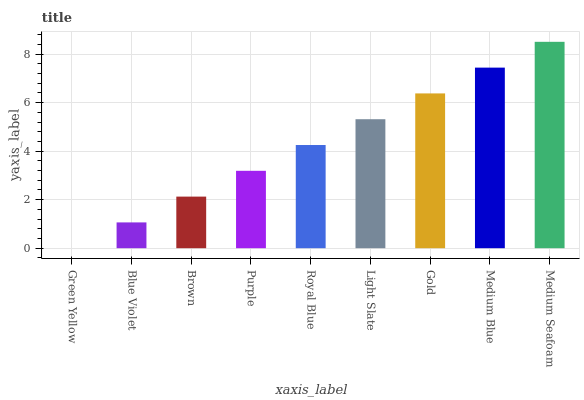Is Green Yellow the minimum?
Answer yes or no. Yes. Is Medium Seafoam the maximum?
Answer yes or no. Yes. Is Blue Violet the minimum?
Answer yes or no. No. Is Blue Violet the maximum?
Answer yes or no. No. Is Blue Violet greater than Green Yellow?
Answer yes or no. Yes. Is Green Yellow less than Blue Violet?
Answer yes or no. Yes. Is Green Yellow greater than Blue Violet?
Answer yes or no. No. Is Blue Violet less than Green Yellow?
Answer yes or no. No. Is Royal Blue the high median?
Answer yes or no. Yes. Is Royal Blue the low median?
Answer yes or no. Yes. Is Green Yellow the high median?
Answer yes or no. No. Is Light Slate the low median?
Answer yes or no. No. 